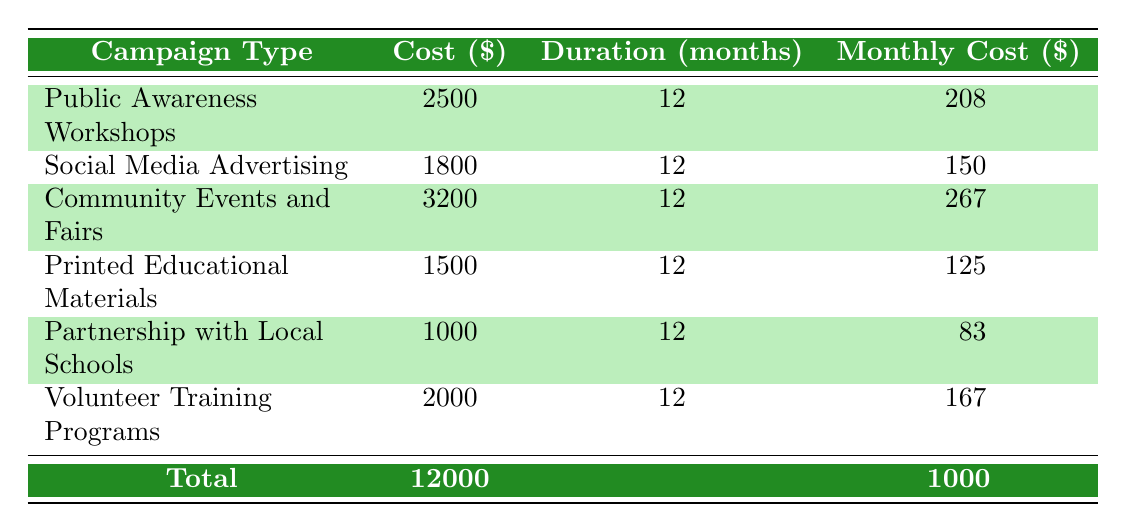What is the total annual cost of all campaigns listed? The table lists six different campaigns with their respective costs. To find the total annual cost, we sum up all the costs: 2500 + 1800 + 3200 + 1500 + 1000 + 2000 = 12000.
Answer: 12000 Which campaign has the highest monthly cost? To determine which campaign has the highest monthly cost, we look at the "Monthly Cost" column. The values are 208, 150, 267, 125, 83, and 167. The highest value is 267 for the "Community Events and Fairs" campaign.
Answer: Community Events and Fairs Is the cost of "Printed Educational Materials" higher than that of "Partnership with Local Schools"? We compare the costs for the two campaigns. "Printed Educational Materials" has a cost of 1500, while "Partnership with Local Schools" has a cost of 1000. Since 1500 is greater than 1000, the statement is true.
Answer: Yes What is the average monthly cost of all campaigns? To find the average monthly cost, we first sum the monthly costs: 208 + 150 + 267 + 125 + 83 + 167 = 1000. We then divide this total by the number of campaigns, which is 6. So, 1000 / 6 = 166.67.
Answer: 166.67 Are there any campaigns with a duration of fewer than 12 months? All campaigns in the table have a "Duration" of 12 months. Since none have a duration less than that, the statement is false.
Answer: No Which campaign type has a cost of 2500? By examining the table, we find that the "Public Awareness Workshops" campaign has a cost of 2500.
Answer: Public Awareness Workshops What is the difference in cost between the most expensive and the least expensive campaign? The most expensive campaign is "Community Events and Fairs" at 3200, and the least expensive is "Partnership with Local Schools" at 1000. The difference in cost is calculated as 3200 - 1000 = 2200.
Answer: 2200 Which campaign type incurs a monthly cost of 125? Looking at the "Monthly Cost" column, we see that "Printed Educational Materials" has a monthly cost of 125.
Answer: Printed Educational Materials 